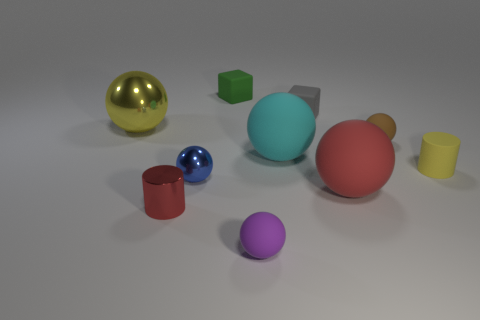Subtract all large cyan balls. How many balls are left? 5 Subtract all cubes. How many objects are left? 8 Subtract 1 balls. How many balls are left? 5 Subtract all red balls. How many balls are left? 5 Subtract all cyan cubes. How many yellow balls are left? 1 Subtract all small rubber spheres. Subtract all metal balls. How many objects are left? 6 Add 4 large red matte objects. How many large red matte objects are left? 5 Add 4 small cylinders. How many small cylinders exist? 6 Subtract 1 purple balls. How many objects are left? 9 Subtract all red cubes. Subtract all gray balls. How many cubes are left? 2 